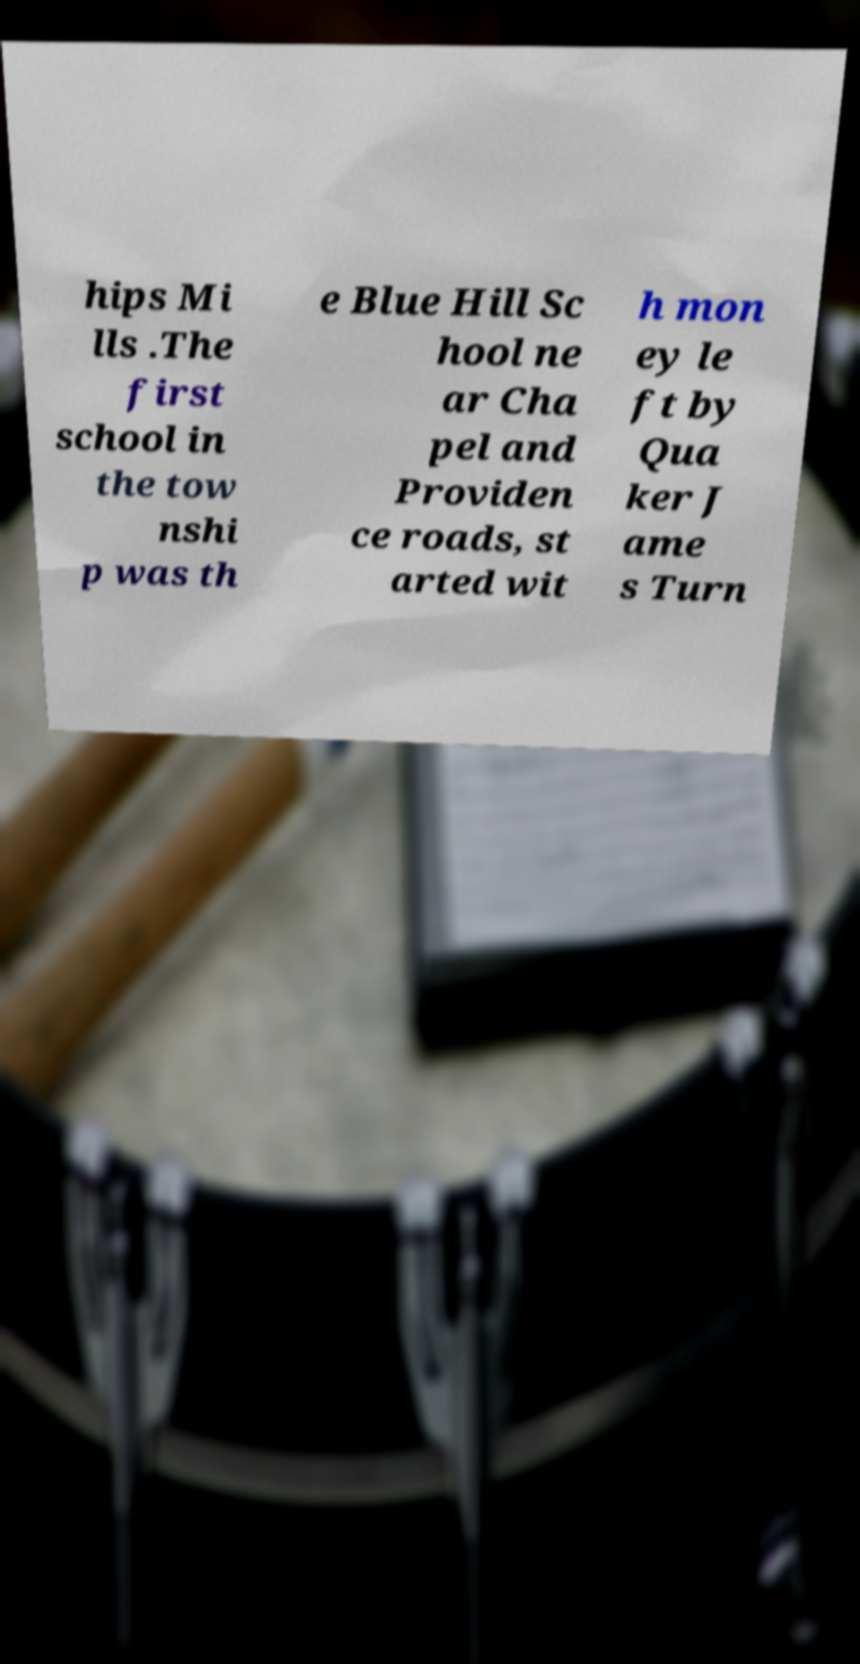What messages or text are displayed in this image? I need them in a readable, typed format. hips Mi lls .The first school in the tow nshi p was th e Blue Hill Sc hool ne ar Cha pel and Providen ce roads, st arted wit h mon ey le ft by Qua ker J ame s Turn 